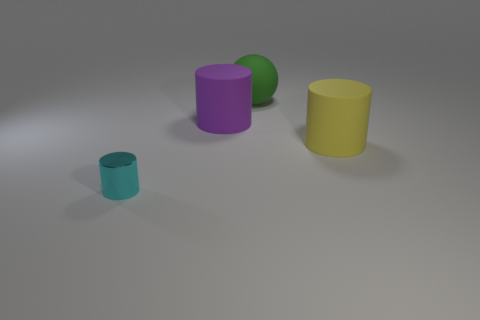There is a thing that is both right of the large purple cylinder and left of the yellow cylinder; what size is it?
Offer a terse response. Large. There is a big thing behind the big purple rubber cylinder; is its color the same as the rubber cylinder that is on the right side of the green object?
Offer a very short reply. No. What number of other objects are the same material as the purple object?
Keep it short and to the point. 2. What shape is the large object that is both in front of the big green rubber object and left of the large yellow cylinder?
Offer a terse response. Cylinder. There is a metal cylinder; is its color the same as the rubber cylinder that is on the left side of the large green rubber sphere?
Your answer should be very brief. No. There is a rubber object to the right of the green rubber ball; does it have the same size as the small thing?
Give a very brief answer. No. What is the material of the yellow object that is the same shape as the cyan shiny thing?
Offer a very short reply. Rubber. Is the big green object the same shape as the purple rubber thing?
Your response must be concise. No. There is a rubber thing that is in front of the purple object; how many big purple matte cylinders are to the left of it?
Ensure brevity in your answer.  1. The purple object that is made of the same material as the big green ball is what shape?
Your answer should be very brief. Cylinder. 